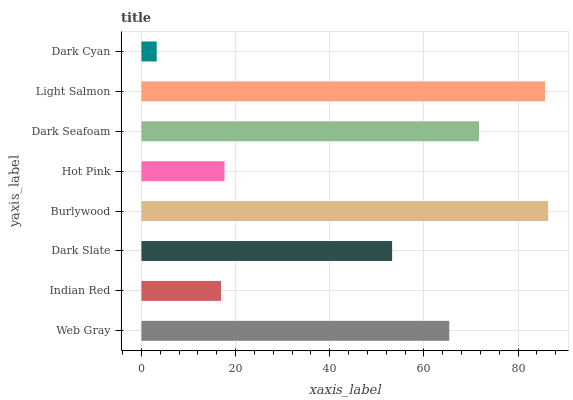Is Dark Cyan the minimum?
Answer yes or no. Yes. Is Burlywood the maximum?
Answer yes or no. Yes. Is Indian Red the minimum?
Answer yes or no. No. Is Indian Red the maximum?
Answer yes or no. No. Is Web Gray greater than Indian Red?
Answer yes or no. Yes. Is Indian Red less than Web Gray?
Answer yes or no. Yes. Is Indian Red greater than Web Gray?
Answer yes or no. No. Is Web Gray less than Indian Red?
Answer yes or no. No. Is Web Gray the high median?
Answer yes or no. Yes. Is Dark Slate the low median?
Answer yes or no. Yes. Is Dark Seafoam the high median?
Answer yes or no. No. Is Dark Cyan the low median?
Answer yes or no. No. 